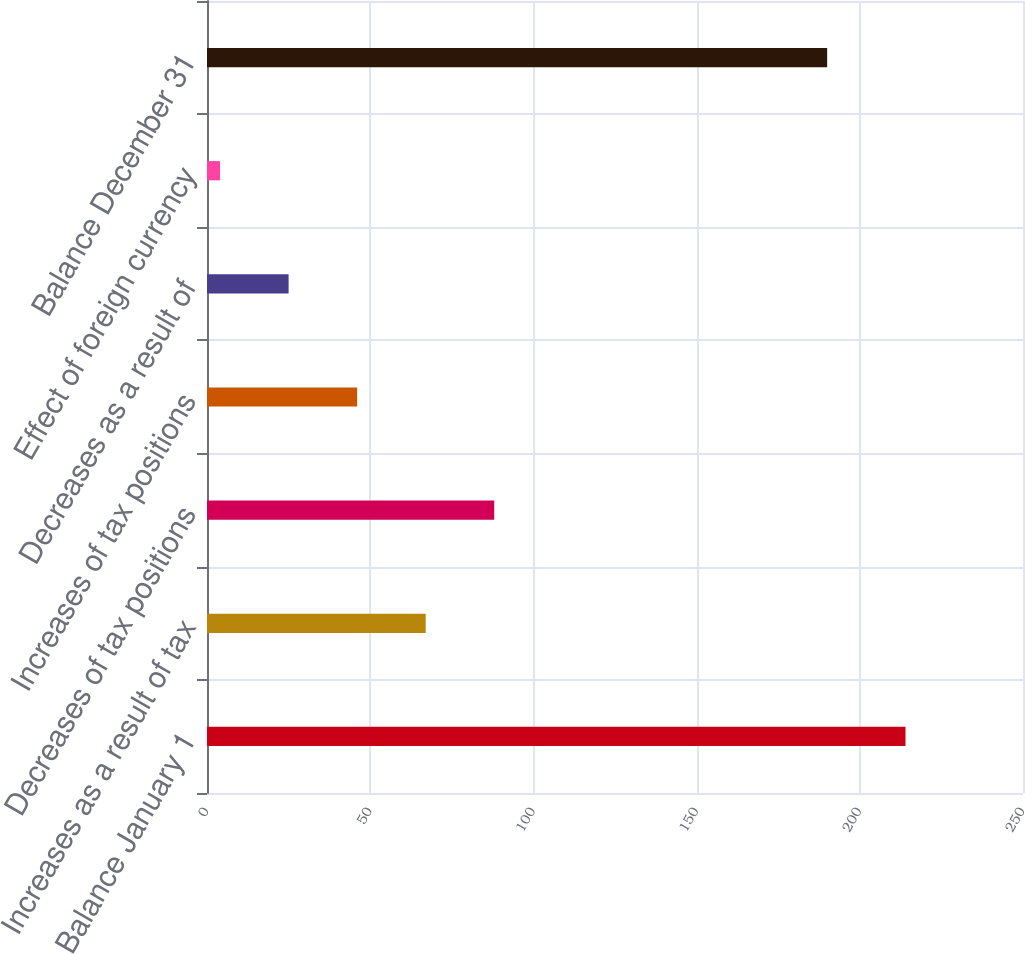<chart> <loc_0><loc_0><loc_500><loc_500><bar_chart><fcel>Balance January 1<fcel>Increases as a result of tax<fcel>Decreases of tax positions<fcel>Increases of tax positions<fcel>Decreases as a result of<fcel>Effect of foreign currency<fcel>Balance December 31<nl><fcel>214<fcel>67<fcel>88<fcel>46<fcel>25<fcel>4<fcel>190<nl></chart> 